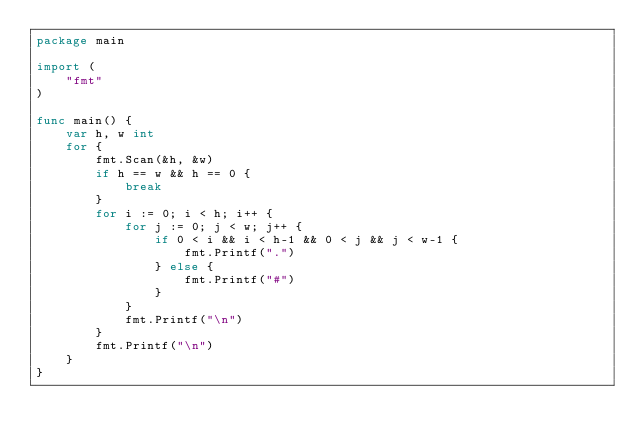<code> <loc_0><loc_0><loc_500><loc_500><_Go_>package main

import (
	"fmt"
)

func main() {
	var h, w int
	for {
		fmt.Scan(&h, &w)
		if h == w && h == 0 {
			break
		}
		for i := 0; i < h; i++ {
			for j := 0; j < w; j++ {
				if 0 < i && i < h-1 && 0 < j && j < w-1 {
					fmt.Printf(".")
				} else {
					fmt.Printf("#")
				}
			}
			fmt.Printf("\n")
		}
		fmt.Printf("\n")
	}
}

</code> 